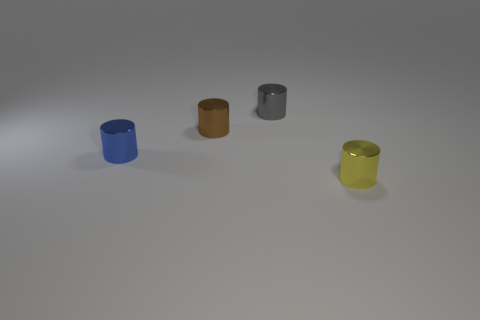Are all the objects of the same size? They appear similar in size, but without precise measurement, it's not possible to confirm if they are exactly the same size. 